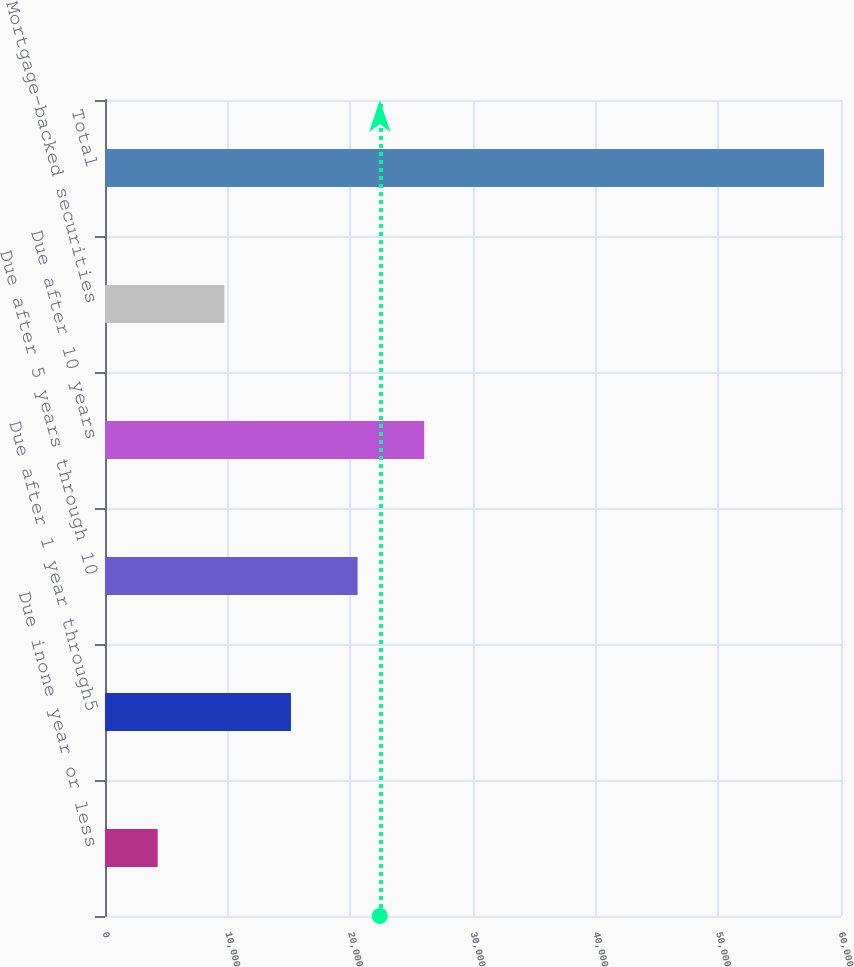<chart> <loc_0><loc_0><loc_500><loc_500><bar_chart><fcel>Due inone year or less<fcel>Due after 1 year through5<fcel>Due after 5 years through 10<fcel>Due after 10 years<fcel>Mortgage-backed securities<fcel>Total<nl><fcel>4296<fcel>15160<fcel>20592<fcel>26024<fcel>9728<fcel>58616<nl></chart> 